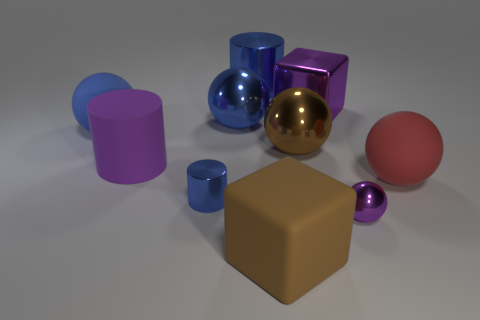Subtract all brown spheres. How many spheres are left? 4 Subtract all red spheres. How many spheres are left? 4 Subtract 2 balls. How many balls are left? 3 Subtract all gray spheres. Subtract all green blocks. How many spheres are left? 5 Subtract all cylinders. How many objects are left? 7 Subtract 0 cyan cylinders. How many objects are left? 10 Subtract all large blue matte balls. Subtract all purple shiny blocks. How many objects are left? 8 Add 7 large matte cubes. How many large matte cubes are left? 8 Add 5 large rubber cubes. How many large rubber cubes exist? 6 